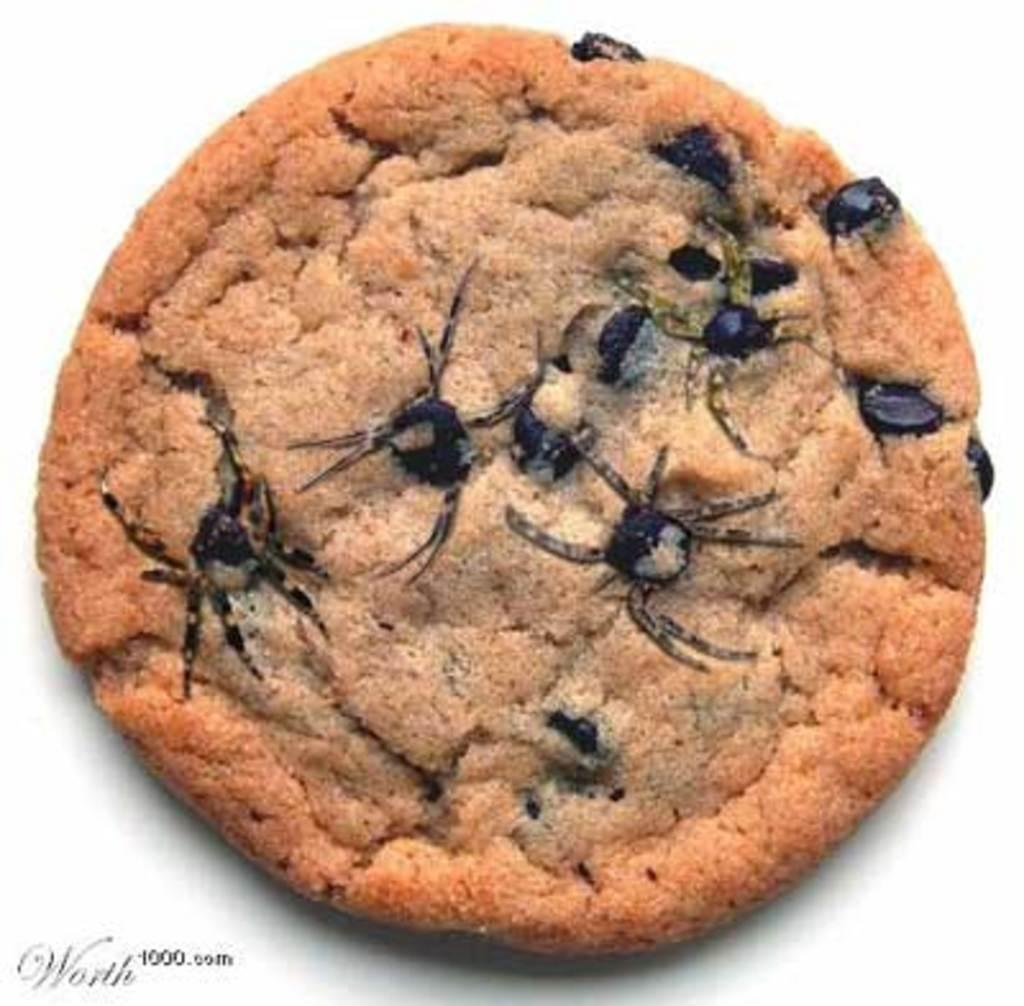What type of cookie is shown in the image? There is a brown-colored cookie in the image. What can be seen on the surface of the cookie? There are black-colored things on the cookie. Is there any text or logo visible in the image? Yes, there is a watermark in the bottom left corner of the image. Can you tell me how many worms are crawling on the cookie in the image? There are no worms present on the cookie in the image. What sense is being stimulated by the cookie in the image? The image is visual, so the sense being stimulated is sight. 